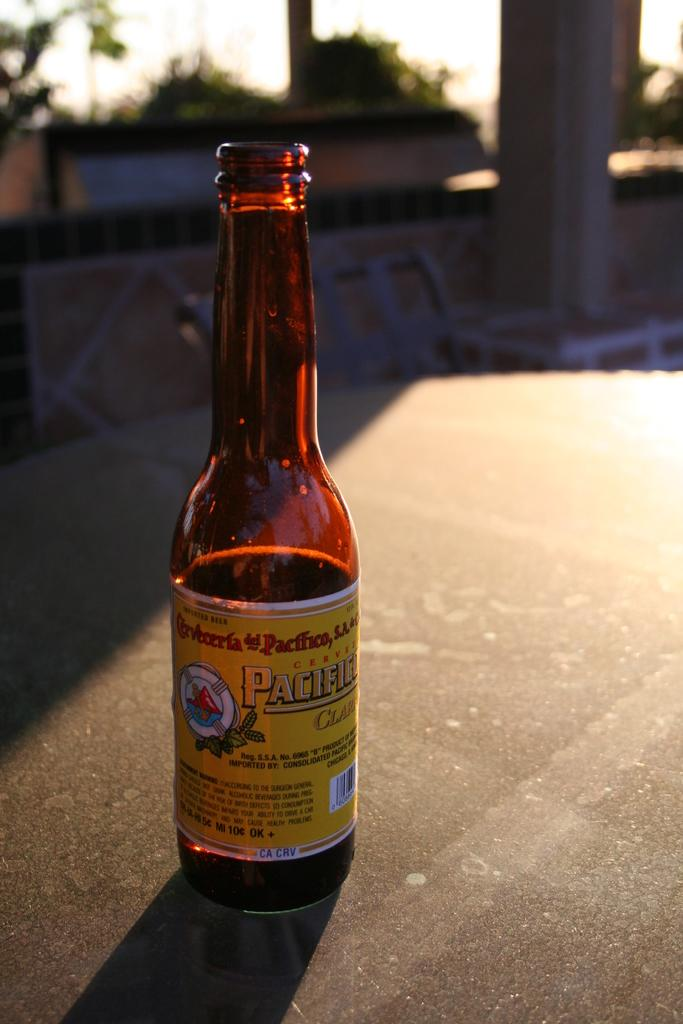What object can be seen in the image? There is a bottle in the image. What type of natural scenery is present in the image? There are trees in the image. What type of print can be seen on the bottle in the image? There is no print visible on the bottle in the image. How much dirt is present around the trees in the image? The image does not provide information about the amount of dirt around the trees. 